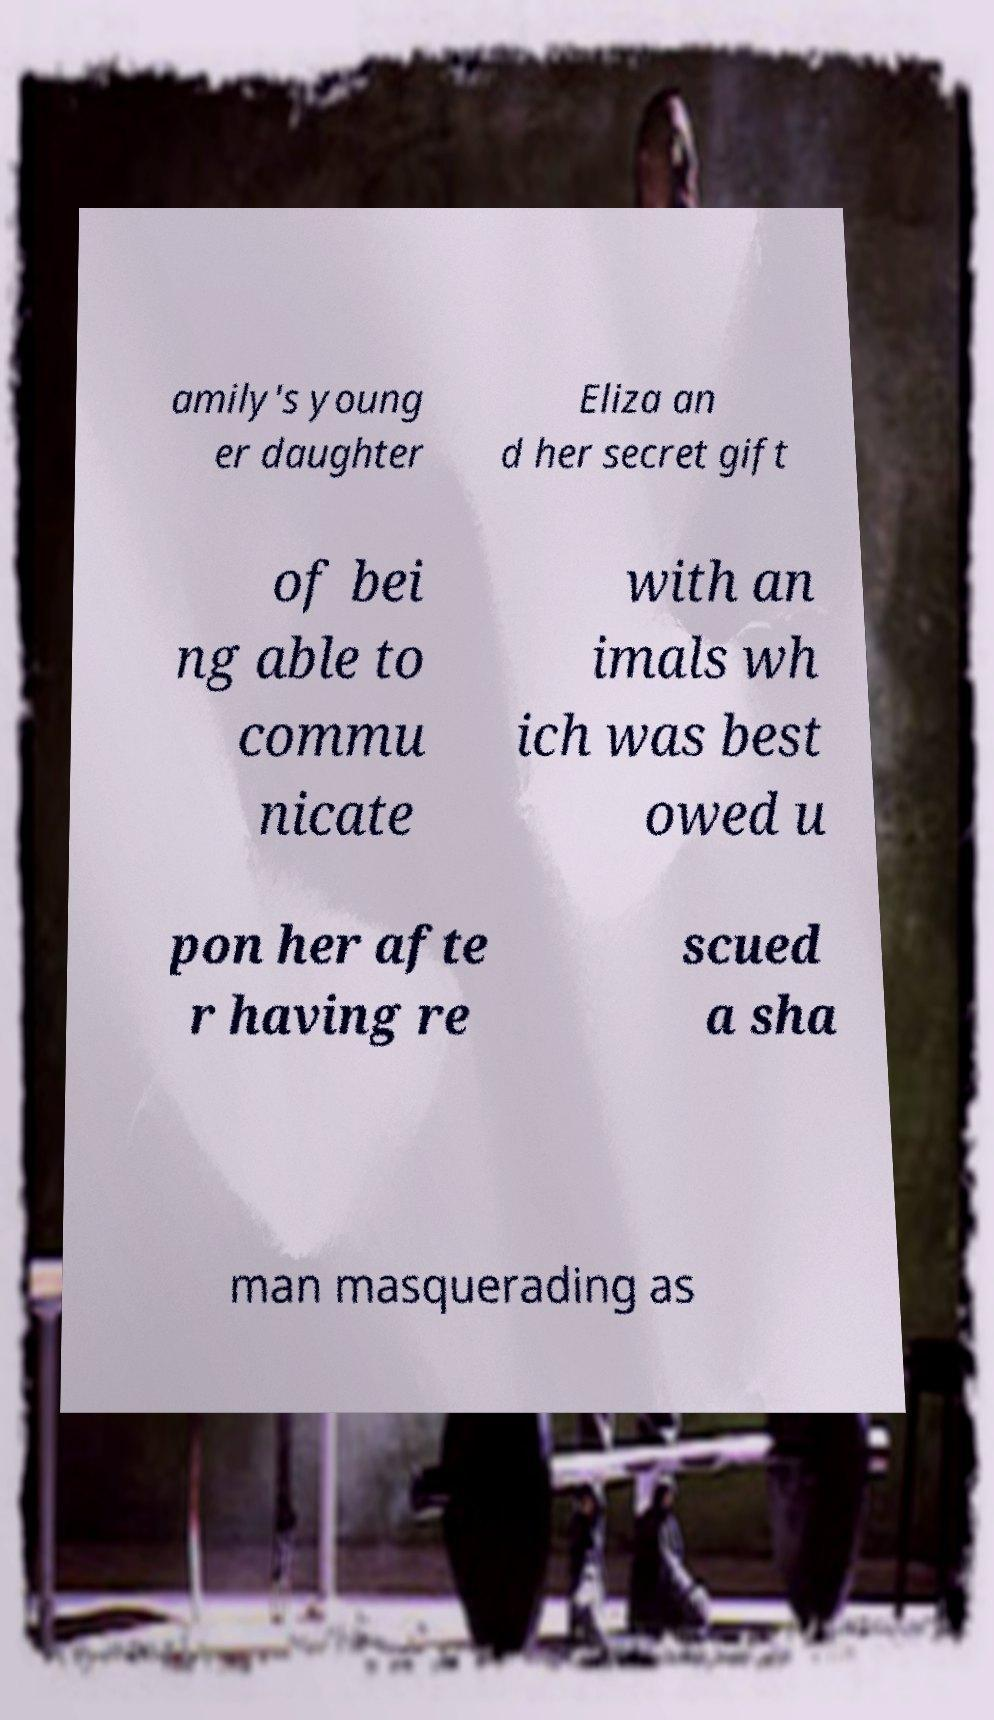Can you read and provide the text displayed in the image?This photo seems to have some interesting text. Can you extract and type it out for me? amily's young er daughter Eliza an d her secret gift of bei ng able to commu nicate with an imals wh ich was best owed u pon her afte r having re scued a sha man masquerading as 